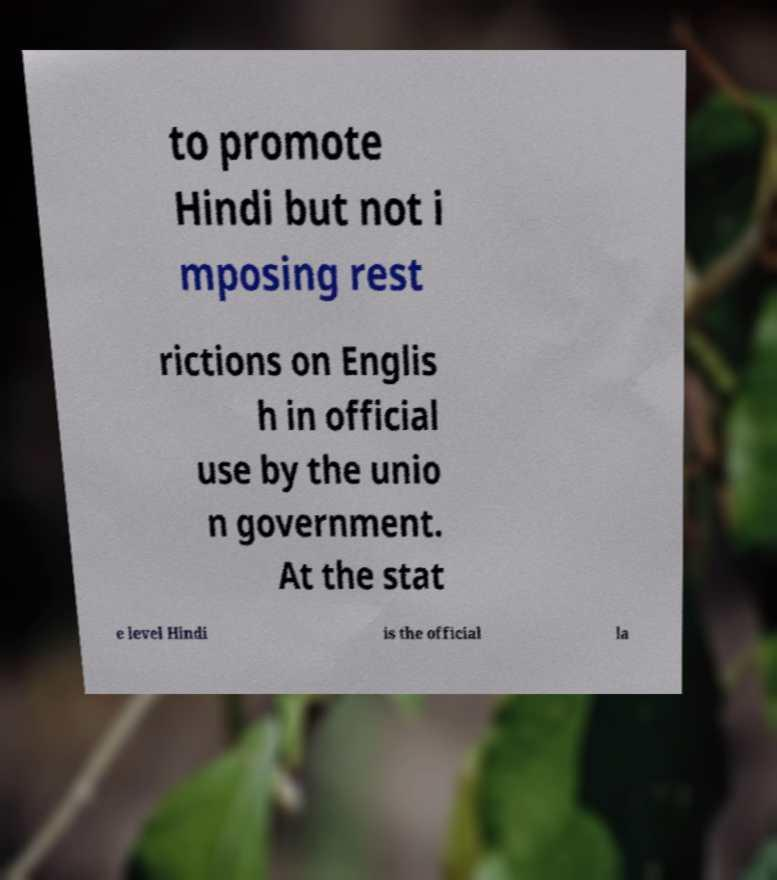Please identify and transcribe the text found in this image. to promote Hindi but not i mposing rest rictions on Englis h in official use by the unio n government. At the stat e level Hindi is the official la 